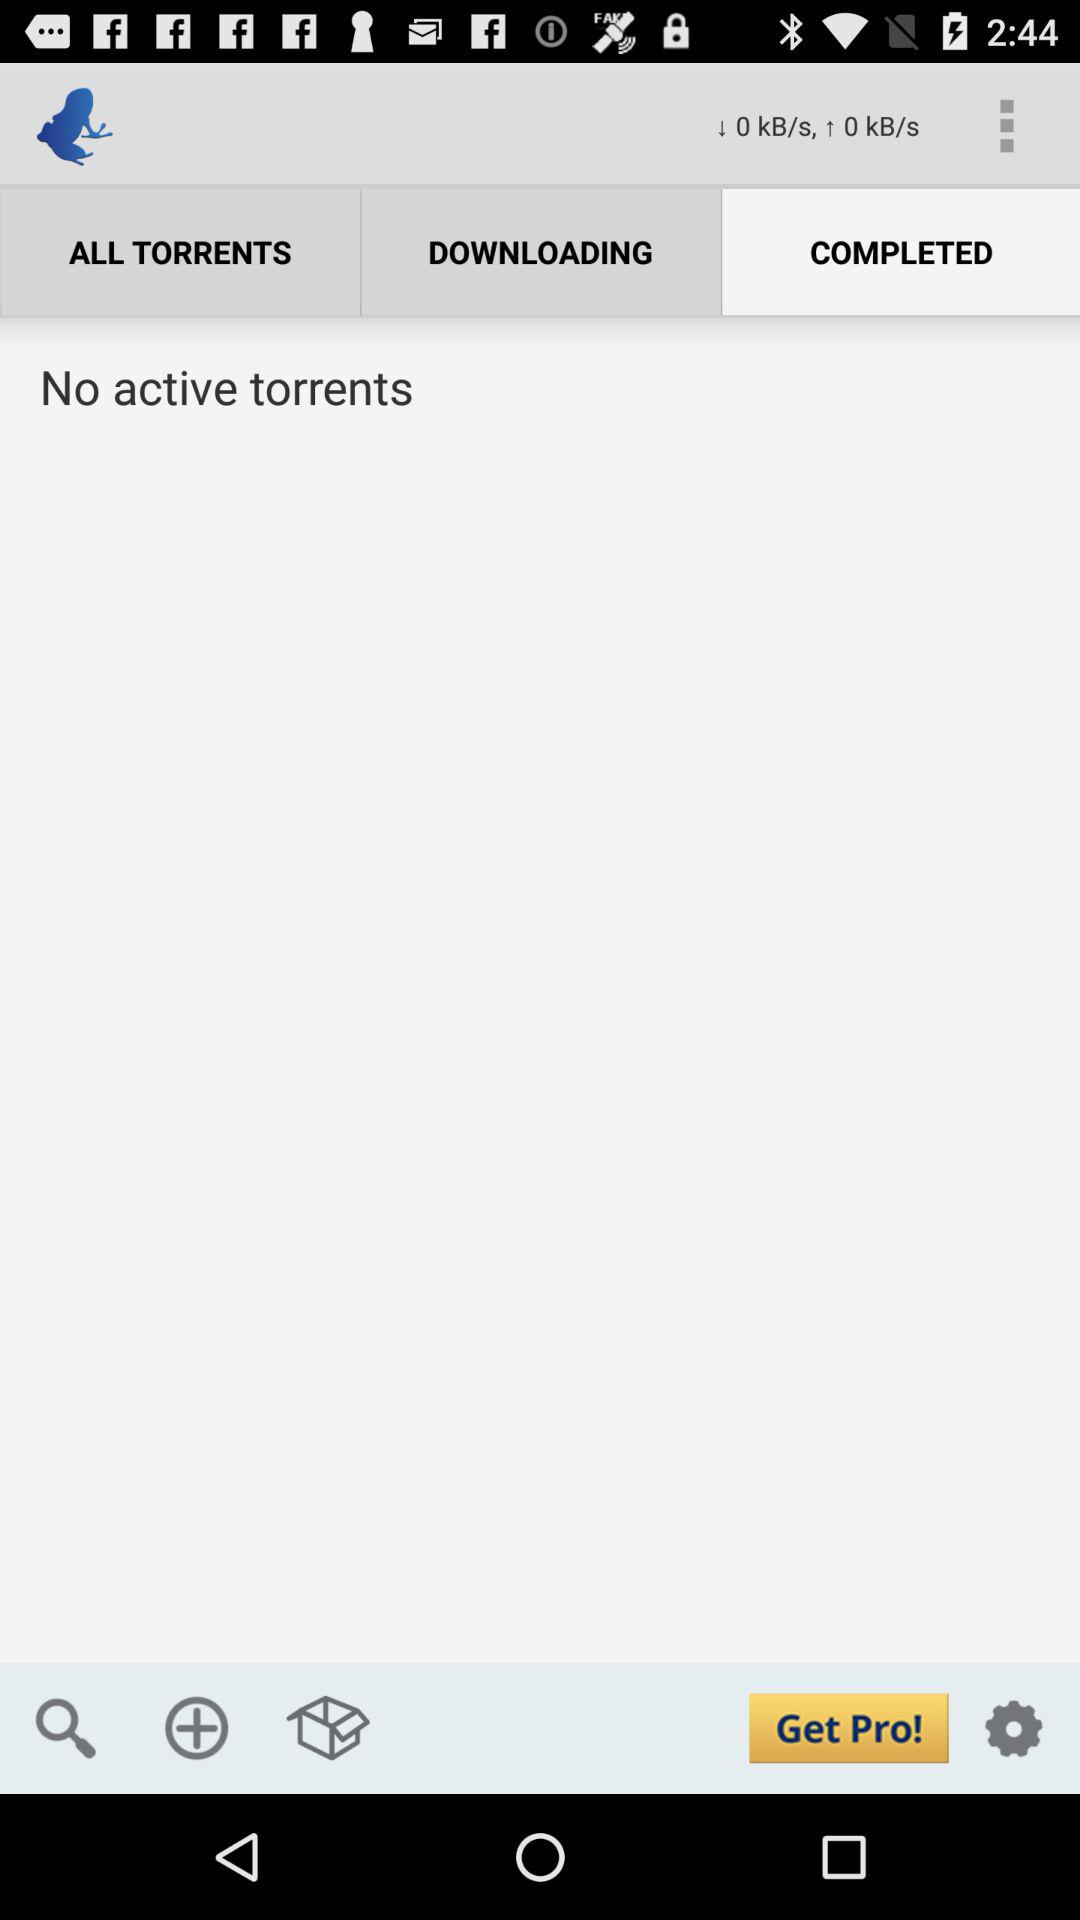What can you infer about the version of the app displayed in the image? Based on the 'Get Pro' button in the lower right corner of the app, it's likely this is a free version of the app, and there is a professional or premium version available that users can upgrade to, possibly offering more features or an ad-free experience. 